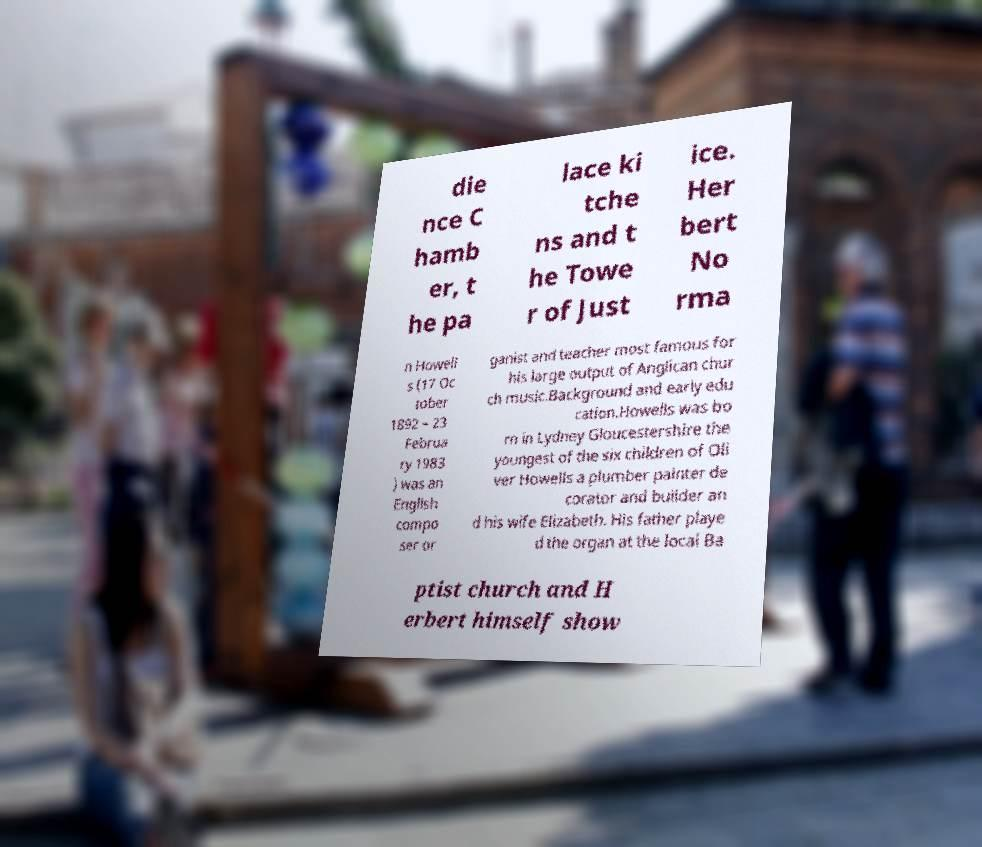Could you extract and type out the text from this image? die nce C hamb er, t he pa lace ki tche ns and t he Towe r of Just ice. Her bert No rma n Howell s (17 Oc tober 1892 – 23 Februa ry 1983 ) was an English compo ser or ganist and teacher most famous for his large output of Anglican chur ch music.Background and early edu cation.Howells was bo rn in Lydney Gloucestershire the youngest of the six children of Oli ver Howells a plumber painter de corator and builder an d his wife Elizabeth. His father playe d the organ at the local Ba ptist church and H erbert himself show 